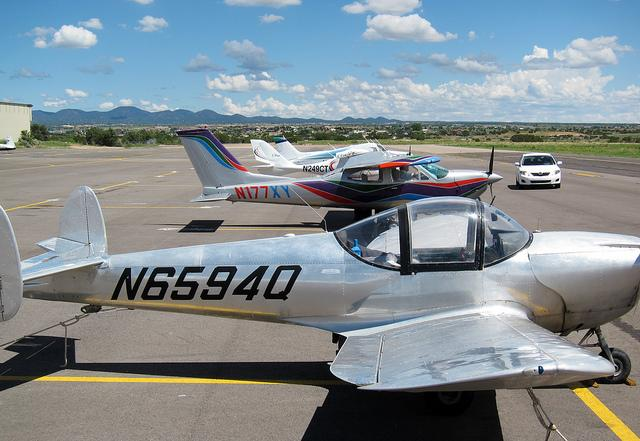What are cables hooked to these planes for? Please explain your reasoning. holding steady. The cables hold the plane down. 